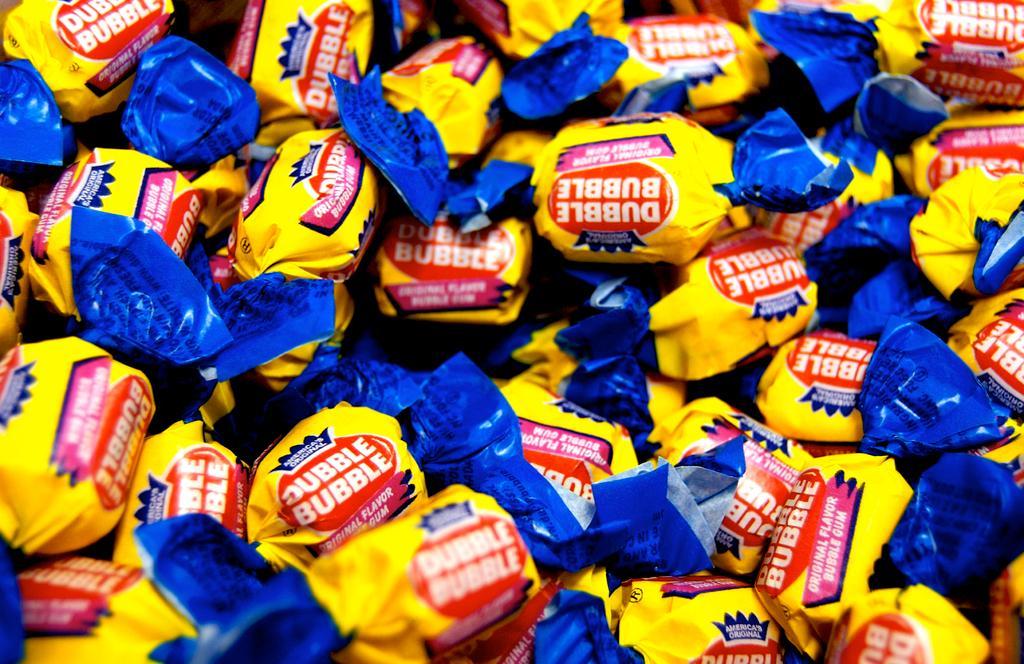How would you summarize this image in a sentence or two? In this picture I can see there are few candies and they are wrapped with yellow and blue papers. There is something written on it. 